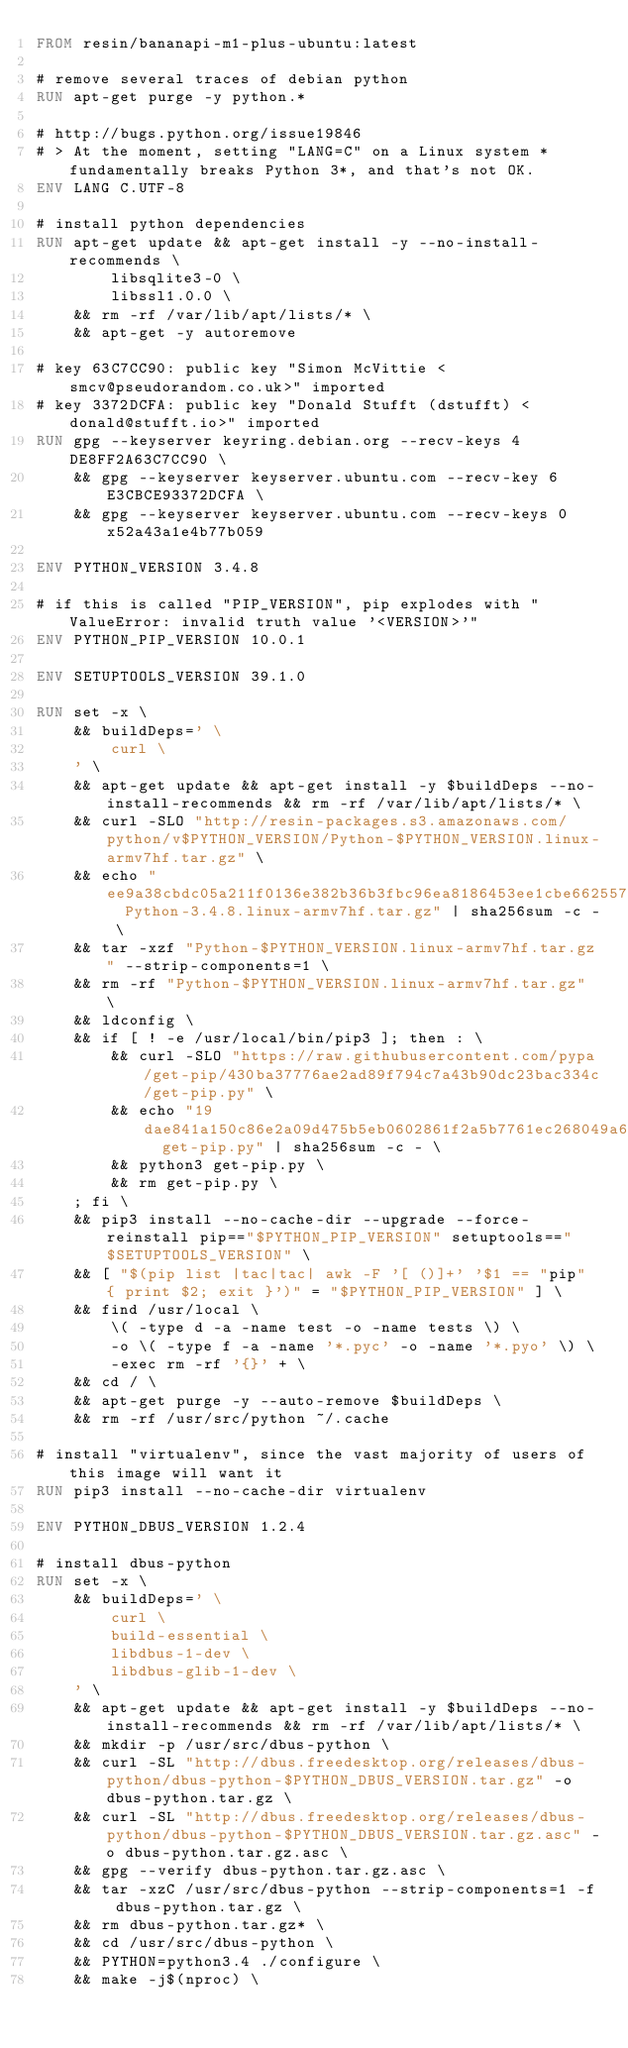<code> <loc_0><loc_0><loc_500><loc_500><_Dockerfile_>FROM resin/bananapi-m1-plus-ubuntu:latest

# remove several traces of debian python
RUN apt-get purge -y python.*

# http://bugs.python.org/issue19846
# > At the moment, setting "LANG=C" on a Linux system *fundamentally breaks Python 3*, and that's not OK.
ENV LANG C.UTF-8

# install python dependencies
RUN apt-get update && apt-get install -y --no-install-recommends \
		libsqlite3-0 \
		libssl1.0.0 \
	&& rm -rf /var/lib/apt/lists/* \
	&& apt-get -y autoremove

# key 63C7CC90: public key "Simon McVittie <smcv@pseudorandom.co.uk>" imported
# key 3372DCFA: public key "Donald Stufft (dstufft) <donald@stufft.io>" imported
RUN gpg --keyserver keyring.debian.org --recv-keys 4DE8FF2A63C7CC90 \
	&& gpg --keyserver keyserver.ubuntu.com --recv-key 6E3CBCE93372DCFA \
	&& gpg --keyserver keyserver.ubuntu.com --recv-keys 0x52a43a1e4b77b059

ENV PYTHON_VERSION 3.4.8

# if this is called "PIP_VERSION", pip explodes with "ValueError: invalid truth value '<VERSION>'"
ENV PYTHON_PIP_VERSION 10.0.1

ENV SETUPTOOLS_VERSION 39.1.0

RUN set -x \
	&& buildDeps=' \
		curl \
	' \
	&& apt-get update && apt-get install -y $buildDeps --no-install-recommends && rm -rf /var/lib/apt/lists/* \
	&& curl -SLO "http://resin-packages.s3.amazonaws.com/python/v$PYTHON_VERSION/Python-$PYTHON_VERSION.linux-armv7hf.tar.gz" \
	&& echo "ee9a38cbdc05a211f0136e382b36b3fbc96ea8186453ee1cbe66255707de6836  Python-3.4.8.linux-armv7hf.tar.gz" | sha256sum -c - \
	&& tar -xzf "Python-$PYTHON_VERSION.linux-armv7hf.tar.gz" --strip-components=1 \
	&& rm -rf "Python-$PYTHON_VERSION.linux-armv7hf.tar.gz" \
	&& ldconfig \
	&& if [ ! -e /usr/local/bin/pip3 ]; then : \
		&& curl -SLO "https://raw.githubusercontent.com/pypa/get-pip/430ba37776ae2ad89f794c7a43b90dc23bac334c/get-pip.py" \
		&& echo "19dae841a150c86e2a09d475b5eb0602861f2a5b7761ec268049a662dbd2bd0c  get-pip.py" | sha256sum -c - \
		&& python3 get-pip.py \
		&& rm get-pip.py \
	; fi \
	&& pip3 install --no-cache-dir --upgrade --force-reinstall pip=="$PYTHON_PIP_VERSION" setuptools=="$SETUPTOOLS_VERSION" \
	&& [ "$(pip list |tac|tac| awk -F '[ ()]+' '$1 == "pip" { print $2; exit }')" = "$PYTHON_PIP_VERSION" ] \
	&& find /usr/local \
		\( -type d -a -name test -o -name tests \) \
		-o \( -type f -a -name '*.pyc' -o -name '*.pyo' \) \
		-exec rm -rf '{}' + \
	&& cd / \
	&& apt-get purge -y --auto-remove $buildDeps \
	&& rm -rf /usr/src/python ~/.cache

# install "virtualenv", since the vast majority of users of this image will want it
RUN pip3 install --no-cache-dir virtualenv

ENV PYTHON_DBUS_VERSION 1.2.4

# install dbus-python
RUN set -x \
	&& buildDeps=' \
		curl \
		build-essential \
		libdbus-1-dev \
		libdbus-glib-1-dev \
	' \
	&& apt-get update && apt-get install -y $buildDeps --no-install-recommends && rm -rf /var/lib/apt/lists/* \
	&& mkdir -p /usr/src/dbus-python \
	&& curl -SL "http://dbus.freedesktop.org/releases/dbus-python/dbus-python-$PYTHON_DBUS_VERSION.tar.gz" -o dbus-python.tar.gz \
	&& curl -SL "http://dbus.freedesktop.org/releases/dbus-python/dbus-python-$PYTHON_DBUS_VERSION.tar.gz.asc" -o dbus-python.tar.gz.asc \
	&& gpg --verify dbus-python.tar.gz.asc \
	&& tar -xzC /usr/src/dbus-python --strip-components=1 -f dbus-python.tar.gz \
	&& rm dbus-python.tar.gz* \
	&& cd /usr/src/dbus-python \
	&& PYTHON=python3.4 ./configure \
	&& make -j$(nproc) \</code> 